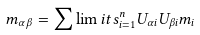<formula> <loc_0><loc_0><loc_500><loc_500>m _ { \alpha \beta } = \sum \lim i t s _ { i = 1 } ^ { n } U _ { \alpha i } U _ { \beta i } m _ { i }</formula> 